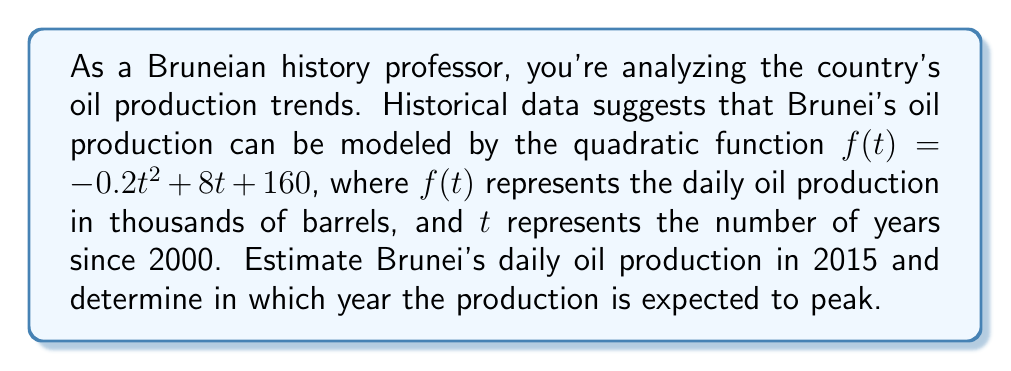Show me your answer to this math problem. To solve this problem, we need to use the given quadratic function and perform the following steps:

1. Estimate the daily oil production in 2015:
   - 2015 is 15 years after 2000, so we need to calculate $f(15)$
   - $f(15) = -0.2(15)^2 + 8(15) + 160$
   - $f(15) = -0.2(225) + 120 + 160$
   - $f(15) = -45 + 120 + 160 = 235$

2. Determine the year when production peaks:
   - The peak of a quadratic function occurs at the vertex of the parabola
   - For a quadratic function in the form $f(t) = at^2 + bt + c$, the t-coordinate of the vertex is given by $t = -\frac{b}{2a}$
   - In our function, $a = -0.2$ and $b = 8$
   - $t = -\frac{8}{2(-0.2)} = -\frac{8}{-0.4} = 20$
   - The peak occurs 20 years after 2000, which is the year 2020

3. Verify the peak year:
   - We can confirm this by checking that $f(19) < f(20) > f(21)$
   - $f(19) = -0.2(19)^2 + 8(19) + 160 = 239.8$
   - $f(20) = -0.2(20)^2 + 8(20) + 160 = 240$
   - $f(21) = -0.2(21)^2 + 8(21) + 160 = 239.8$
   - This confirms that the peak occurs at $t = 20$, or the year 2020
Answer: Brunei's estimated daily oil production in 2015 is 235,000 barrels. The production is expected to peak in the year 2020. 